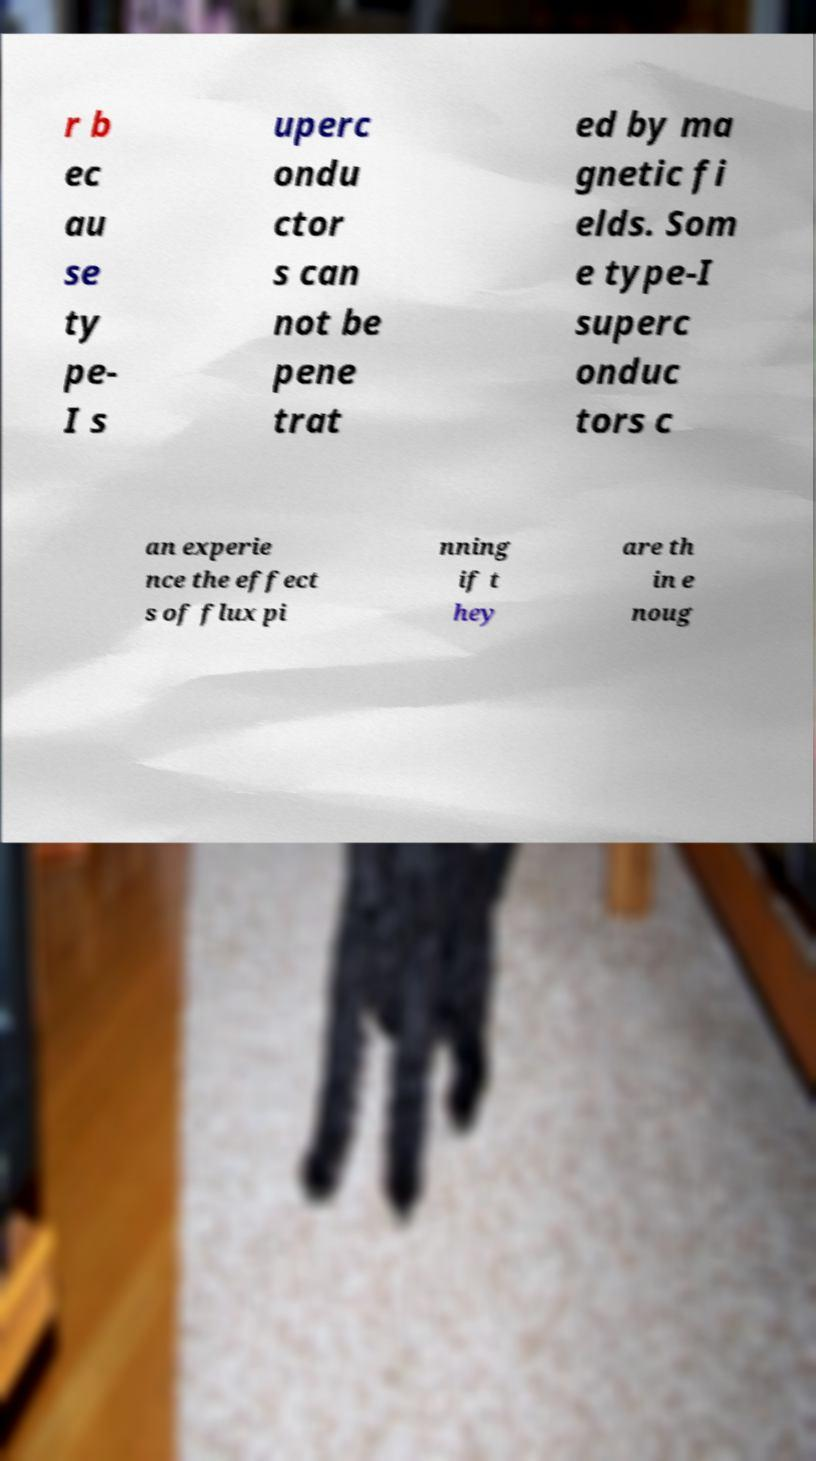There's text embedded in this image that I need extracted. Can you transcribe it verbatim? r b ec au se ty pe- I s uperc ondu ctor s can not be pene trat ed by ma gnetic fi elds. Som e type-I superc onduc tors c an experie nce the effect s of flux pi nning if t hey are th in e noug 